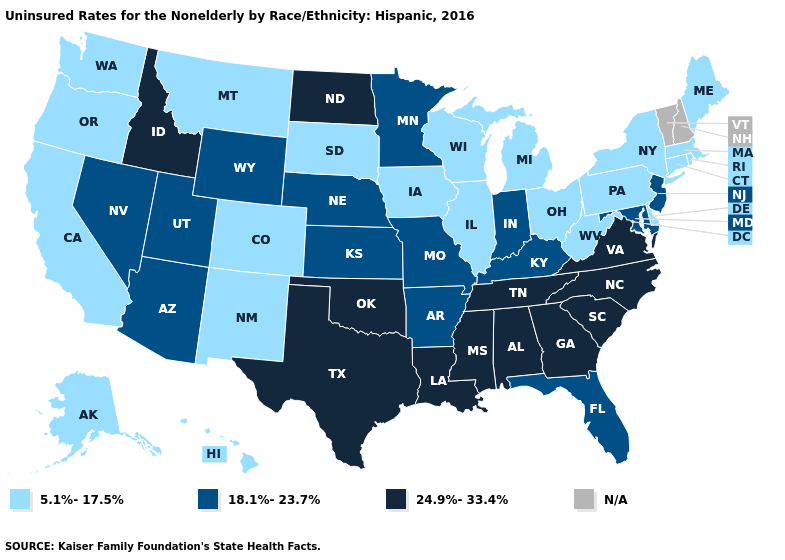Name the states that have a value in the range 24.9%-33.4%?
Quick response, please. Alabama, Georgia, Idaho, Louisiana, Mississippi, North Carolina, North Dakota, Oklahoma, South Carolina, Tennessee, Texas, Virginia. Does Oklahoma have the lowest value in the South?
Short answer required. No. Among the states that border Indiana , does Kentucky have the highest value?
Give a very brief answer. Yes. Does Maine have the highest value in the Northeast?
Give a very brief answer. No. What is the value of Massachusetts?
Be succinct. 5.1%-17.5%. Is the legend a continuous bar?
Concise answer only. No. Name the states that have a value in the range 18.1%-23.7%?
Answer briefly. Arizona, Arkansas, Florida, Indiana, Kansas, Kentucky, Maryland, Minnesota, Missouri, Nebraska, Nevada, New Jersey, Utah, Wyoming. Name the states that have a value in the range 18.1%-23.7%?
Answer briefly. Arizona, Arkansas, Florida, Indiana, Kansas, Kentucky, Maryland, Minnesota, Missouri, Nebraska, Nevada, New Jersey, Utah, Wyoming. What is the highest value in states that border South Carolina?
Quick response, please. 24.9%-33.4%. Name the states that have a value in the range N/A?
Quick response, please. New Hampshire, Vermont. Name the states that have a value in the range N/A?
Concise answer only. New Hampshire, Vermont. Name the states that have a value in the range 5.1%-17.5%?
Answer briefly. Alaska, California, Colorado, Connecticut, Delaware, Hawaii, Illinois, Iowa, Maine, Massachusetts, Michigan, Montana, New Mexico, New York, Ohio, Oregon, Pennsylvania, Rhode Island, South Dakota, Washington, West Virginia, Wisconsin. Which states have the highest value in the USA?
Concise answer only. Alabama, Georgia, Idaho, Louisiana, Mississippi, North Carolina, North Dakota, Oklahoma, South Carolina, Tennessee, Texas, Virginia. 